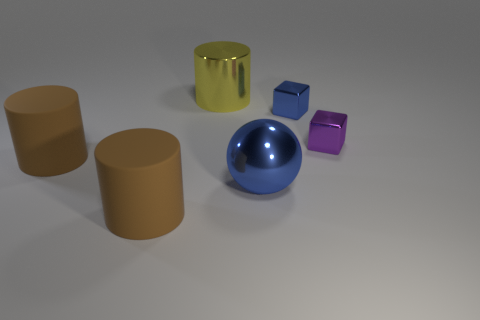Is there a tiny metallic object that is behind the tiny metallic thing right of the tiny blue cube?
Your response must be concise. Yes. What number of other objects are the same color as the large metal cylinder?
Give a very brief answer. 0. What is the color of the big shiny cylinder?
Keep it short and to the point. Yellow. There is a metallic thing that is in front of the small blue thing and behind the big metallic ball; what size is it?
Give a very brief answer. Small. What number of objects are either big rubber things that are in front of the big shiny sphere or metal blocks?
Provide a short and direct response. 3. What is the shape of the big blue thing that is made of the same material as the small blue thing?
Ensure brevity in your answer.  Sphere. There is a big blue thing; what shape is it?
Make the answer very short. Sphere. What color is the metal thing that is both in front of the small blue metallic block and on the left side of the tiny blue metal object?
Ensure brevity in your answer.  Blue. What is the shape of the metal object that is the same size as the yellow metallic cylinder?
Provide a succinct answer. Sphere. Is there another thing that has the same shape as the yellow object?
Keep it short and to the point. Yes. 